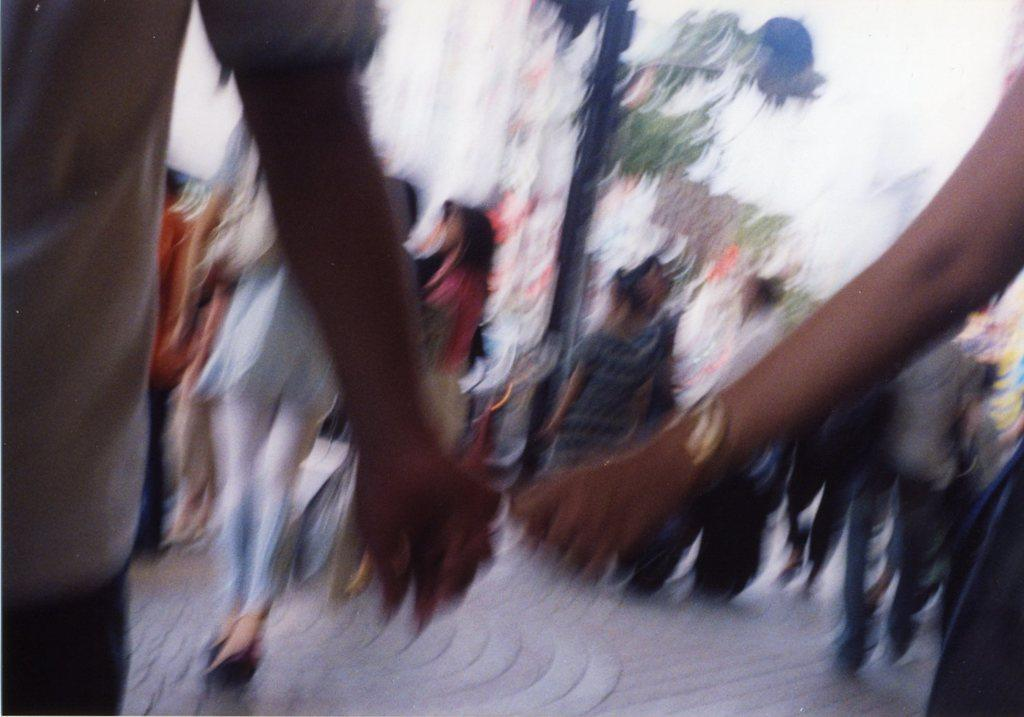What is happening in the image? There are people standing in the image. What are some of the people doing in the image? Some of the people are carrying bags. Can you describe the quality of the image? The image is slightly blurry. What type of gold cord is wrapped around the people in the image? There is no gold cord present in the image; it only shows people standing and carrying bags. 